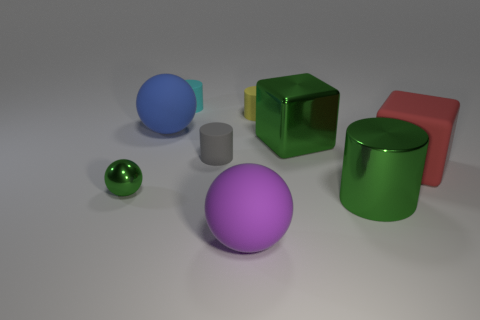The metallic block that is the same size as the rubber cube is what color? green 